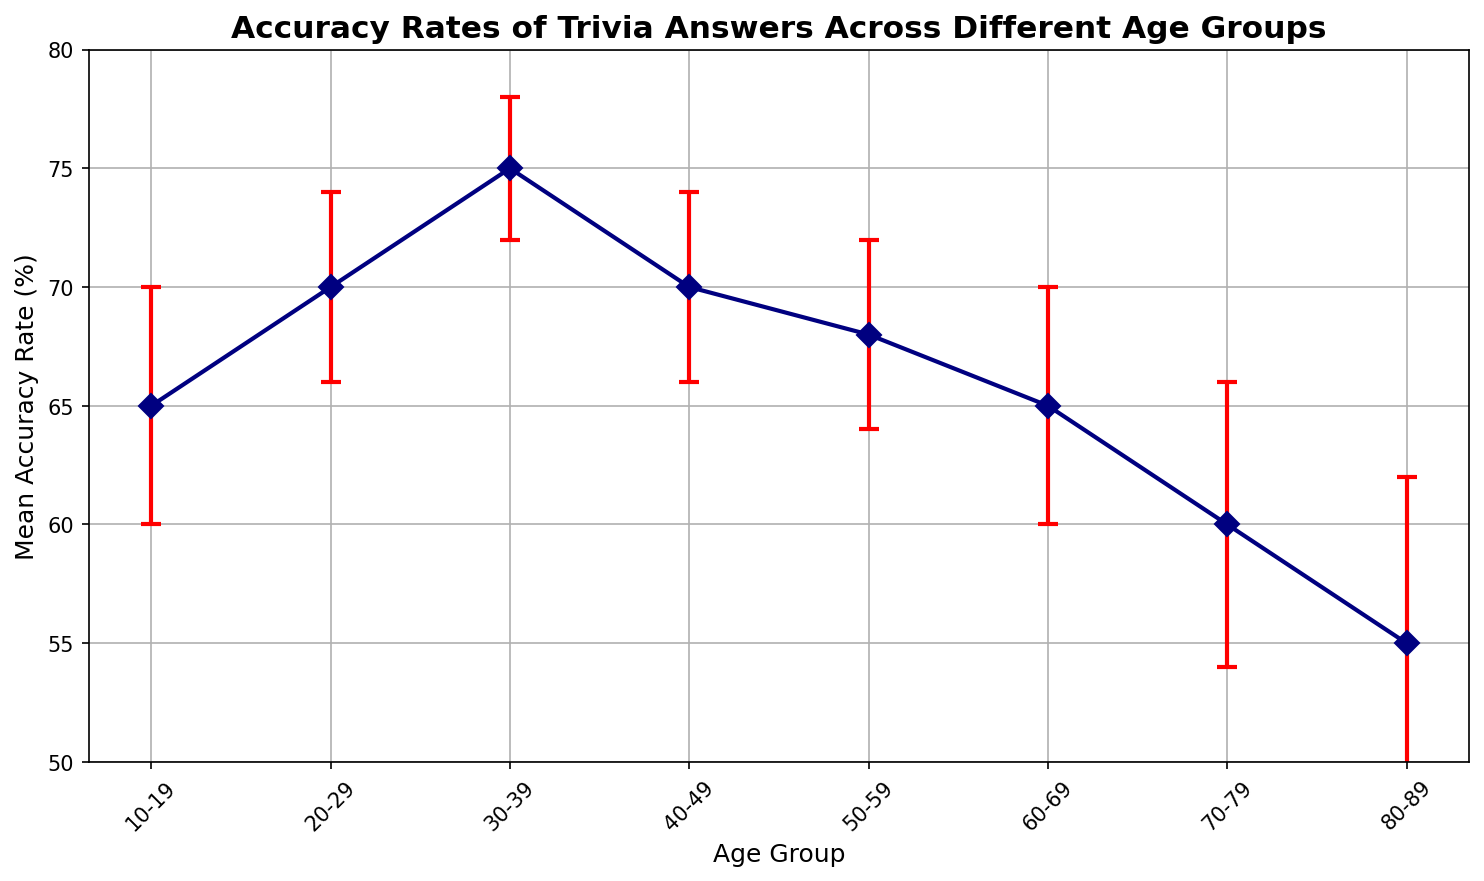Which age group has the highest mean accuracy rate? To determine this, look for the age group with the highest point on the y-axis. The 30-39 age group has the highest mean accuracy rate of 75%.
Answer: 30-39 What is the error margin for the age group 60-69? To find this information, look for the error bars (vertical lines) extending from the data points on the plot. The age group 60-69 has an error margin of 5%.
Answer: 5% How much higher is the mean accuracy rate of the 20-29 age group compared to the 70-79 age group? First, identify the mean accuracy rate of the 20-29 age group (70%) and the 70-79 age group (60%). Subtract the latter from the former: 70% - 60% = 10%.
Answer: 10% Which two age groups have the same error margin of 4%? Identify the error margins on the plot. The age groups 20-29, 40-49, and 50-59 all have an error margin of 4%. Since the question asks for two, we can mention either pair.
Answer: 20-29 and 40-49 What is the range of the mean accuracy rates across all the age groups? The range is calculated by subtracting the lowest mean accuracy rate from the highest mean accuracy rate. The highest is 75% (30-39 age group) and the lowest is 55% (80-89 age group). Range = 75% - 55% = 20%.
Answer: 20% For which age group is the mean accuracy rate exactly equal to the range of error margins across all groups? First, find the range of the error margins: Highest error margin is 7%, and the lowest is 3%. Therefore, the range of error margins is 7% - 3% = 4%. Look for the age group with a mean accuracy rate matching this value. No age group has a mean accuracy rate of 4%, so this question becomes a trick attempt.
Answer: None If you average the error margins of the 10-19 and 80-89 age groups, what do you get? The error margin of the 10-19 age group is 5%, and for the 80-89 age group it is 7%. Calculate the average: (5% + 7%) / 2 = 6%.
Answer: 6% Which age group has a mean accuracy rate closest to the overall average accuracy rate? First, find the overall average by summing all the mean accuracy rates and dividing by the number of groups: (65 + 70 + 75 + 70 + 68 + 65 + 60 + 55) / 8 = 66%. The 50-59 age group with a mean accuracy rate of 68% is closest to this average.
Answer: 50-59 What is the mean error margin for all age groups? Add up all the error margins: 5% + 4% + 3% + 4% + 4% + 5% + 6% + 7%, which equals 38%. Divide this by the number of groups (8): 38% / 8 = 4.75%.
Answer: 4.75% Which age group has the largest error margin, and what is that margin? The largest error margin can be identified by finding the longest vertical line extending from any data point. The 80-89 age group has the largest error margin of 7%.
Answer: 80-89, 7% 